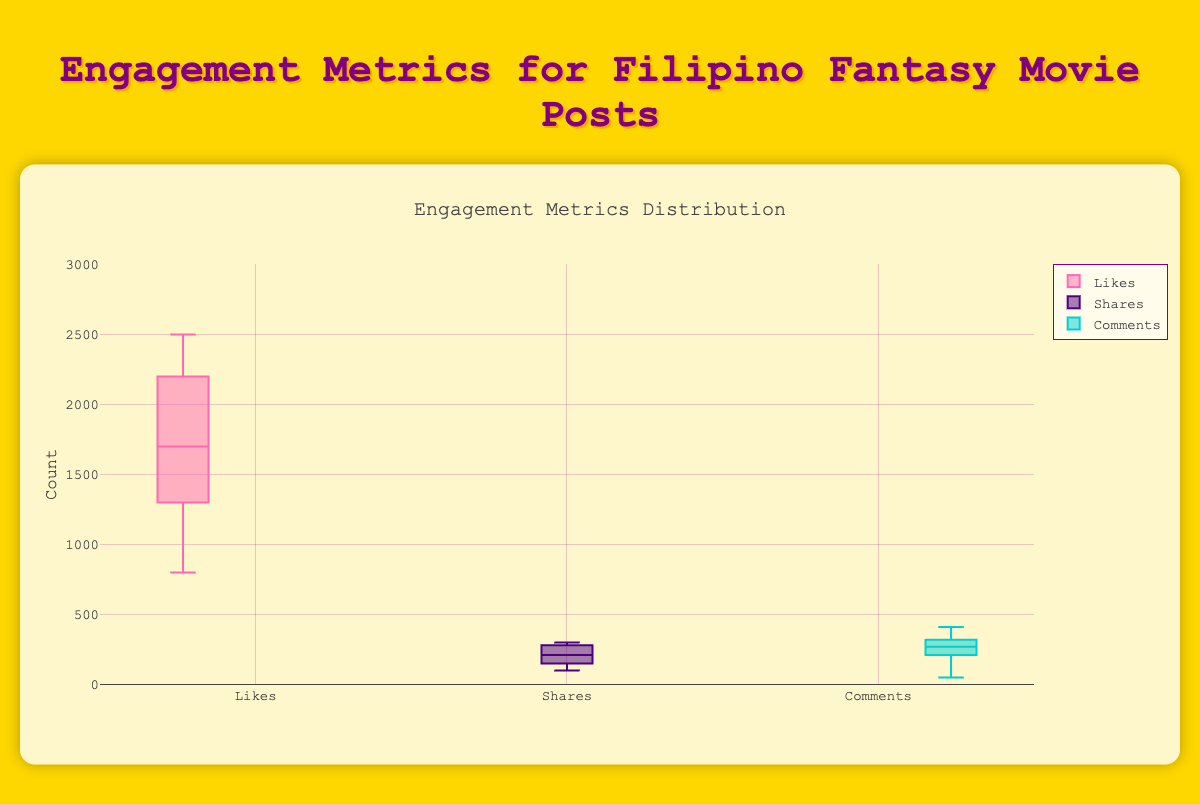What is the median number of likes across all posts? The median value of a dataset is the middle value when the data points are arranged in ascending or descending order. From the box representing 'Likes,' the middle line indicates the median number of likes. By visually inspecting the box plot, the median number of likes is approximately the middle horizontal line of the 'Likes' box.
Answer: 1750 Which engagement metric shows the highest variability? Variability in a data set is indicated by the length of the box and the whiskers in a box plot. The higher the variability, the longer the box and whiskers. By comparing the boxes and whiskers of 'Likes,' 'Shares,' and 'Comments,' the 'Likes' metric has the highest variability as it has the longest box and whiskers.
Answer: Likes What is the range of the number of shares? The range of a dataset is the difference between the maximum and minimum values. In the box plot for 'Shares,' the top whisker corresponds to the maximum number of shares, and the bottom whisker corresponds to the minimum number of shares. Visually, the range for 'Shares' can be estimated as the difference between these whiskers.
Answer: 100-300 Which post has the highest number of comments? By looking at the 'Comments' distribution, the highest number of comments will be a data point at the top whisker or just outside it as an outlier. Referring to the provided data, the highest number of comments corresponds to "Remake of Darna Announced" or "Pedro Penduko Returns: A New Beginning." The actual maximum value can be confirmed as 410 from the data table.
Answer: Remake of Darna Announced/Pedro Penduko Returns: A New Beginning Are there any outliers in the 'Comments' metric? Outliers in a box plot are represented by individual points outside the whiskers. Observing the 'Comments' box plot, any standalone points outside the range of the whiskers indicates outliers. From the figure, there do not appear to be any obvious outliers as all points are within the whiskers.
Answer: No Between ‘Likes’ and ‘Comments’, which metric has a higher median value? The median value is shown by the middle line of each box. Comparing the middle lines of the 'Likes' box and the 'Comments' box, the median for ‘Likes’ is higher than that for ‘Comments’.
Answer: Likes What is the approximate interquartile range (IQR) for likes? The interquartile range (IQR) is the range within which the middle 50% of the data lies. This is represented by the box itself, from the lower quartile to the upper quartile. Visually estimate the distance between the lower quartile (bottom of the box) and the upper quartile (top of the box) for 'Likes'.
Answer: 1500 Comparing ‘Shares’ and ‘Comments’, which metric generally has lower values? Comparing the range and placement of the box plots for ‘Shares’ and ‘Comments’, the box plot for ‘Shares’ generally appears lower on the vertical axis.
Answer: Shares What is the maximum number of likes recorded in the data set? The maximum value in a box plot is represented by the top whisker or the highest point. For 'Likes', the top whisker reaches about the maximum value. From the data table, the exact maximum is 2500.
Answer: 2500 